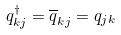Convert formula to latex. <formula><loc_0><loc_0><loc_500><loc_500>q ^ { \dag } _ { k j } = \overline { q } _ { k j } = q _ { j k }</formula> 